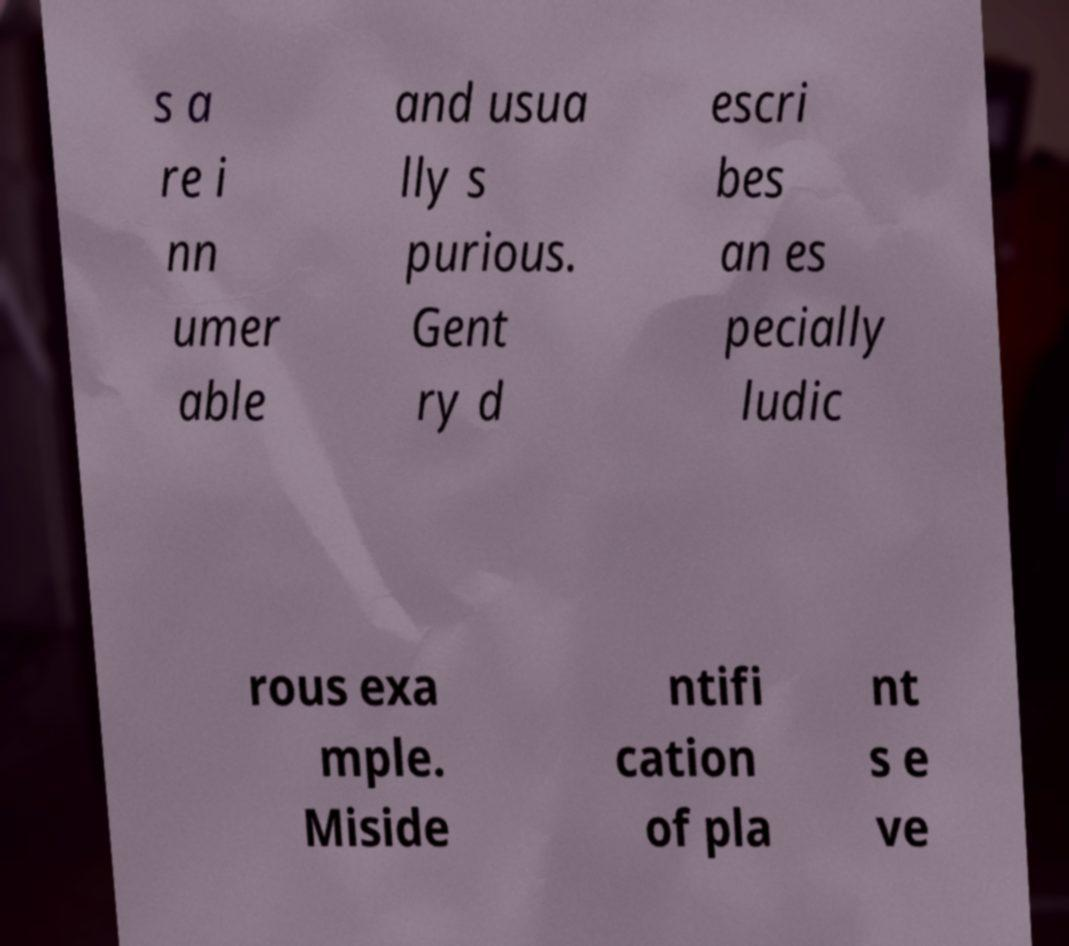What messages or text are displayed in this image? I need them in a readable, typed format. s a re i nn umer able and usua lly s purious. Gent ry d escri bes an es pecially ludic rous exa mple. Miside ntifi cation of pla nt s e ve 